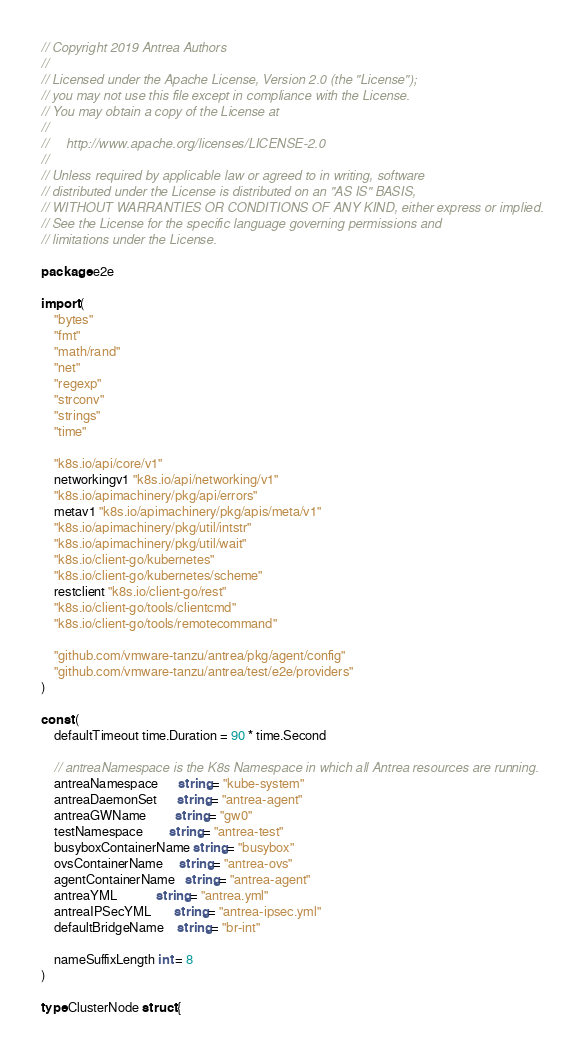Convert code to text. <code><loc_0><loc_0><loc_500><loc_500><_Go_>// Copyright 2019 Antrea Authors
//
// Licensed under the Apache License, Version 2.0 (the "License");
// you may not use this file except in compliance with the License.
// You may obtain a copy of the License at
//
//     http://www.apache.org/licenses/LICENSE-2.0
//
// Unless required by applicable law or agreed to in writing, software
// distributed under the License is distributed on an "AS IS" BASIS,
// WITHOUT WARRANTIES OR CONDITIONS OF ANY KIND, either express or implied.
// See the License for the specific language governing permissions and
// limitations under the License.

package e2e

import (
	"bytes"
	"fmt"
	"math/rand"
	"net"
	"regexp"
	"strconv"
	"strings"
	"time"

	"k8s.io/api/core/v1"
	networkingv1 "k8s.io/api/networking/v1"
	"k8s.io/apimachinery/pkg/api/errors"
	metav1 "k8s.io/apimachinery/pkg/apis/meta/v1"
	"k8s.io/apimachinery/pkg/util/intstr"
	"k8s.io/apimachinery/pkg/util/wait"
	"k8s.io/client-go/kubernetes"
	"k8s.io/client-go/kubernetes/scheme"
	restclient "k8s.io/client-go/rest"
	"k8s.io/client-go/tools/clientcmd"
	"k8s.io/client-go/tools/remotecommand"

	"github.com/vmware-tanzu/antrea/pkg/agent/config"
	"github.com/vmware-tanzu/antrea/test/e2e/providers"
)

const (
	defaultTimeout time.Duration = 90 * time.Second

	// antreaNamespace is the K8s Namespace in which all Antrea resources are running.
	antreaNamespace      string = "kube-system"
	antreaDaemonSet      string = "antrea-agent"
	antreaGWName         string = "gw0"
	testNamespace        string = "antrea-test"
	busyboxContainerName string = "busybox"
	ovsContainerName     string = "antrea-ovs"
	agentContainerName   string = "antrea-agent"
	antreaYML            string = "antrea.yml"
	antreaIPSecYML       string = "antrea-ipsec.yml"
	defaultBridgeName    string = "br-int"

	nameSuffixLength int = 8
)

type ClusterNode struct {</code> 